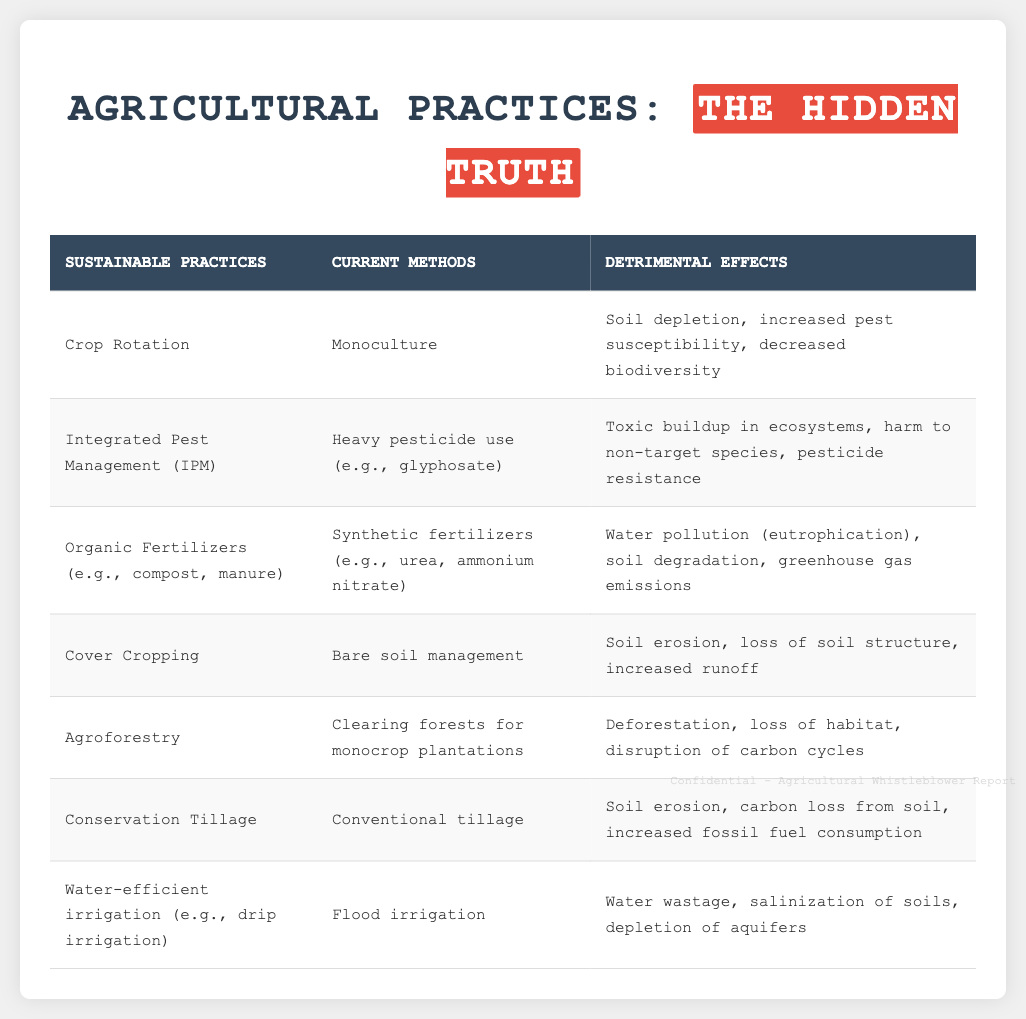What is the first sustainable practice listed? The document presents a comparison table; the first sustainable practice is at the top of the table.
Answer: Crop Rotation What are the detrimental effects of monoculture? Monoculture is in the current methods column; its corresponding detrimental effects are listed next to it.
Answer: Soil depletion, increased pest susceptibility, decreased biodiversity What type of fertilizer is mentioned in current methods? The table lists specific fertilizers for both sustainable and current methods, with current methods highlighted in a separate column.
Answer: Synthetic fertilizers What practice is associated with soil erosion? The detrimental effects are tied to specific practices as listed in the table; the practice related to soil erosion can be found in the sustainable practices column.
Answer: Cover Cropping How many sustainable practices are listed in total? The number of rows under the sustainable practices heading indicates the count of practices in the document.
Answer: Seven What is the detrimental effect of flood irrigation? Flood irrigation is linked with particular detrimental effects listed in the table, found in the last column corresponding to current methods.
Answer: Water wastage Which agricultural practice contributes to deforestation? The document specifies practices in relation to detrimental environmental effects; here, the specific practice identified is in the current methods column.
Answer: Clearing forests for monocrop plantations What is the main environmental concern regarding heavy pesticide use? The detrimental effects of heavy pesticide use are mentioned next to it in the table, directly correlated with this practice.
Answer: Toxic buildup in ecosystems What type of irrigation is considered water-efficient? The sustainable practices column lists this type of irrigation specifically; the details can be found there.
Answer: Drip irrigation 